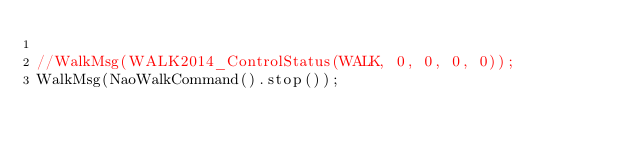Convert code to text. <code><loc_0><loc_0><loc_500><loc_500><_ObjectiveC_>
//WalkMsg(WALK2014_ControlStatus(WALK, 0, 0, 0, 0));
WalkMsg(NaoWalkCommand().stop());
</code> 